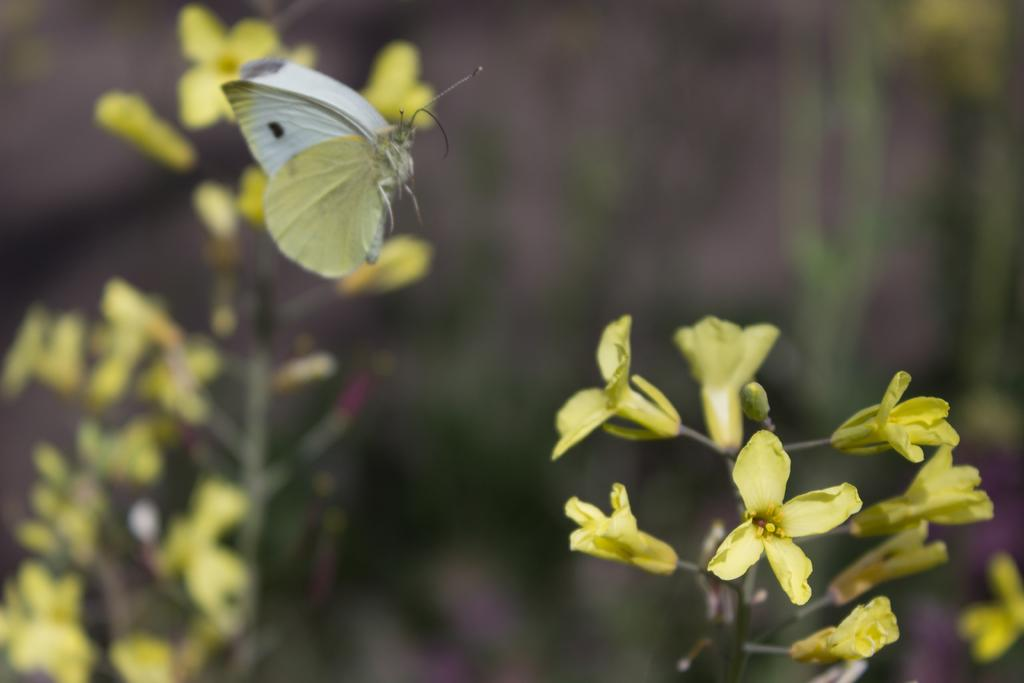What type of plants are in the image? There are flower plants in the image. What other living organism can be seen in the image? There is a butterfly in the image. How would you describe the background of the image? The background of the image is blurry. What role does the father play in the image? There is no father present in the image. What type of team can be seen working together in the image? There is no team present in the image. 